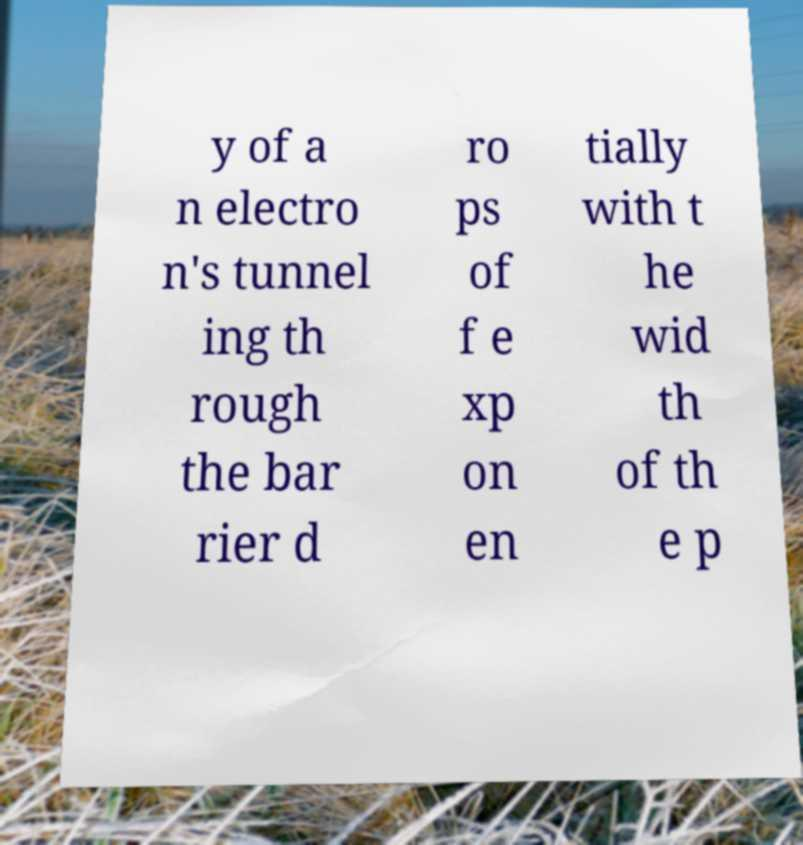Can you accurately transcribe the text from the provided image for me? y of a n electro n's tunnel ing th rough the bar rier d ro ps of f e xp on en tially with t he wid th of th e p 